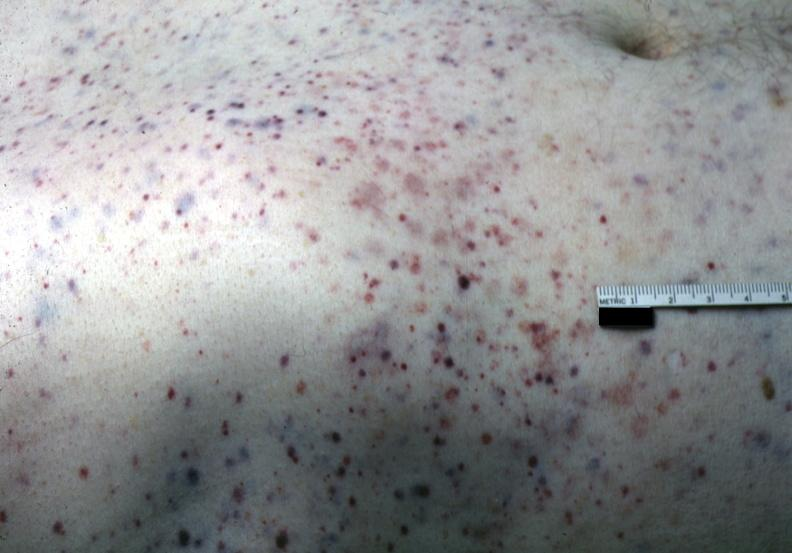s trophic changes present?
Answer the question using a single word or phrase. No 